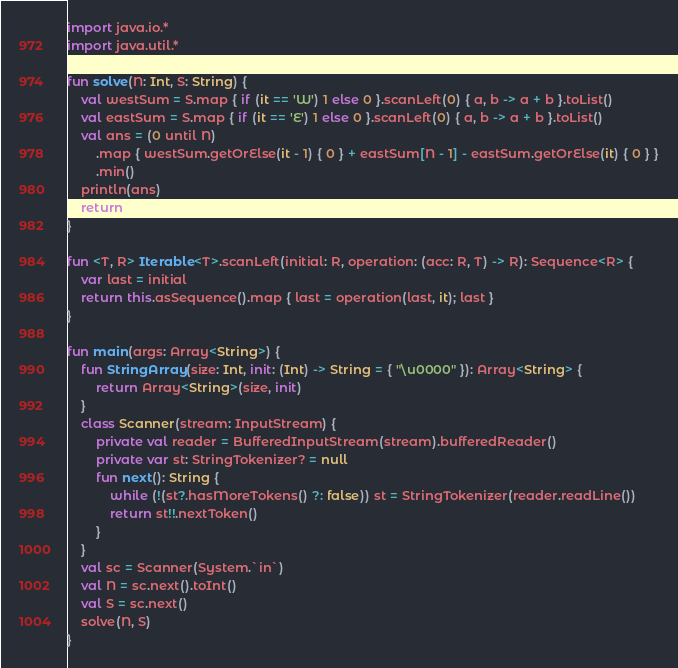Convert code to text. <code><loc_0><loc_0><loc_500><loc_500><_Kotlin_>import java.io.*
import java.util.*

fun solve(N: Int, S: String) {
    val westSum = S.map { if (it == 'W') 1 else 0 }.scanLeft(0) { a, b -> a + b }.toList()
    val eastSum = S.map { if (it == 'E') 1 else 0 }.scanLeft(0) { a, b -> a + b }.toList()
    val ans = (0 until N)
        .map { westSum.getOrElse(it - 1) { 0 } + eastSum[N - 1] - eastSum.getOrElse(it) { 0 } }
        .min()
    println(ans)
    return
}

fun <T, R> Iterable<T>.scanLeft(initial: R, operation: (acc: R, T) -> R): Sequence<R> {
    var last = initial
    return this.asSequence().map { last = operation(last, it); last }
}

fun main(args: Array<String>) {
    fun StringArray(size: Int, init: (Int) -> String = { "\u0000" }): Array<String> {
        return Array<String>(size, init)
    }
    class Scanner(stream: InputStream) {
        private val reader = BufferedInputStream(stream).bufferedReader()
        private var st: StringTokenizer? = null
        fun next(): String {
            while (!(st?.hasMoreTokens() ?: false)) st = StringTokenizer(reader.readLine())
            return st!!.nextToken()
        }
    }
    val sc = Scanner(System.`in`)
    val N = sc.next().toInt()
    val S = sc.next()
    solve(N, S)
}
</code> 